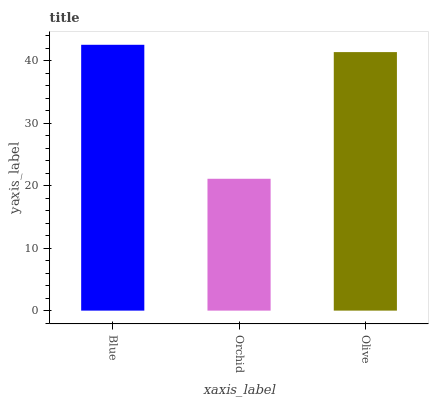Is Orchid the minimum?
Answer yes or no. Yes. Is Blue the maximum?
Answer yes or no. Yes. Is Olive the minimum?
Answer yes or no. No. Is Olive the maximum?
Answer yes or no. No. Is Olive greater than Orchid?
Answer yes or no. Yes. Is Orchid less than Olive?
Answer yes or no. Yes. Is Orchid greater than Olive?
Answer yes or no. No. Is Olive less than Orchid?
Answer yes or no. No. Is Olive the high median?
Answer yes or no. Yes. Is Olive the low median?
Answer yes or no. Yes. Is Blue the high median?
Answer yes or no. No. Is Blue the low median?
Answer yes or no. No. 